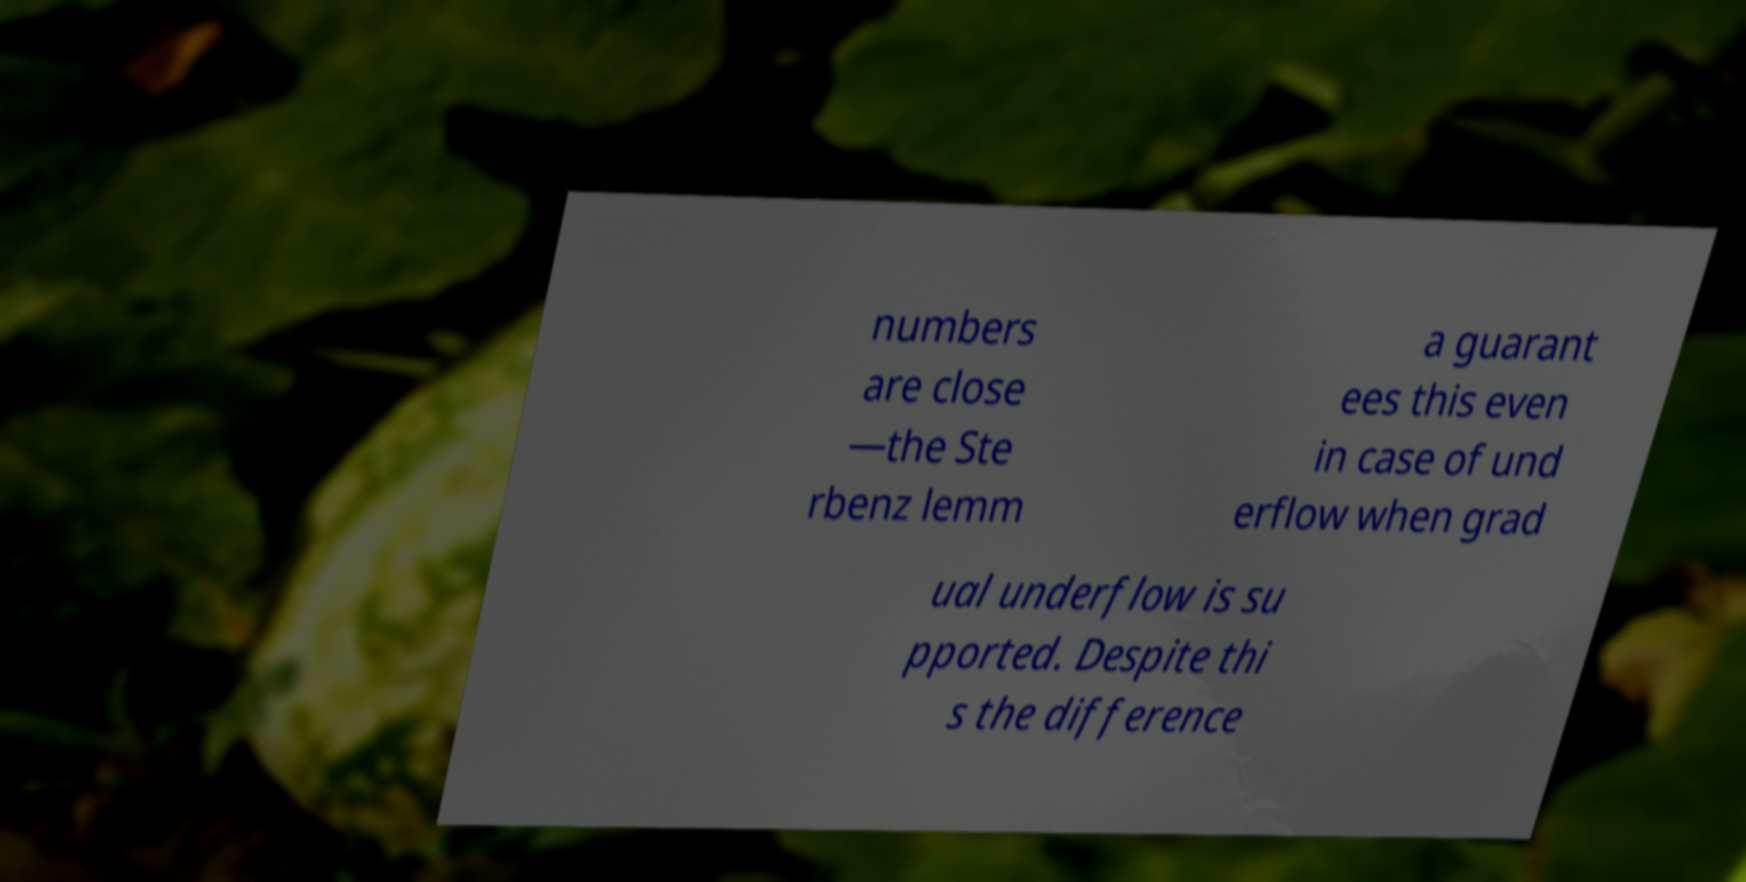Could you assist in decoding the text presented in this image and type it out clearly? numbers are close —the Ste rbenz lemm a guarant ees this even in case of und erflow when grad ual underflow is su pported. Despite thi s the difference 